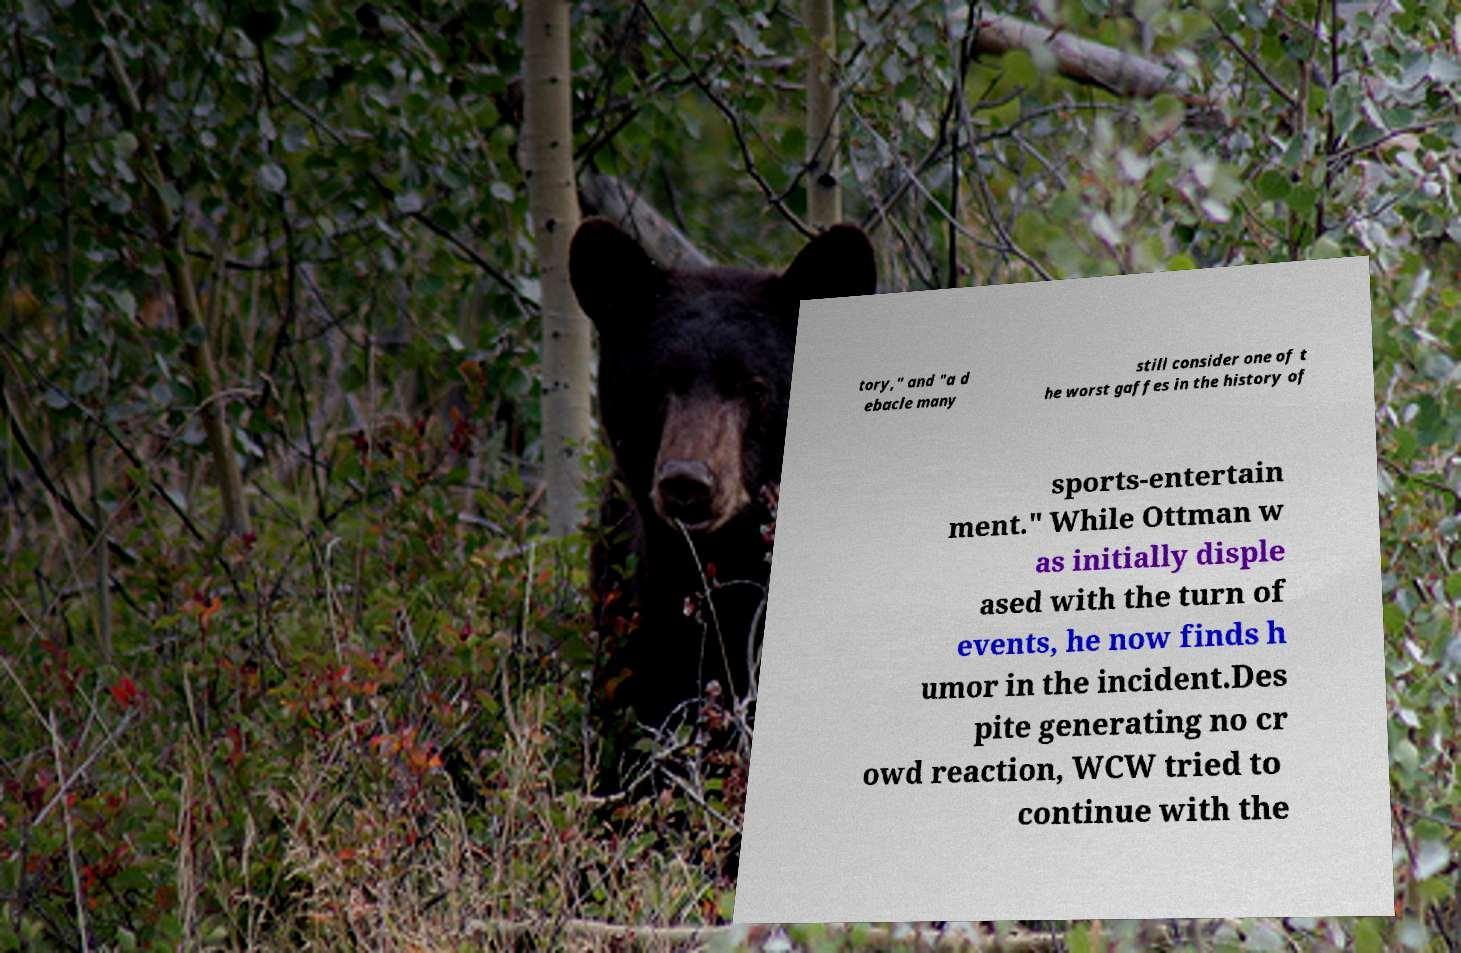Could you extract and type out the text from this image? tory," and "a d ebacle many still consider one of t he worst gaffes in the history of sports-entertain ment." While Ottman w as initially disple ased with the turn of events, he now finds h umor in the incident.Des pite generating no cr owd reaction, WCW tried to continue with the 